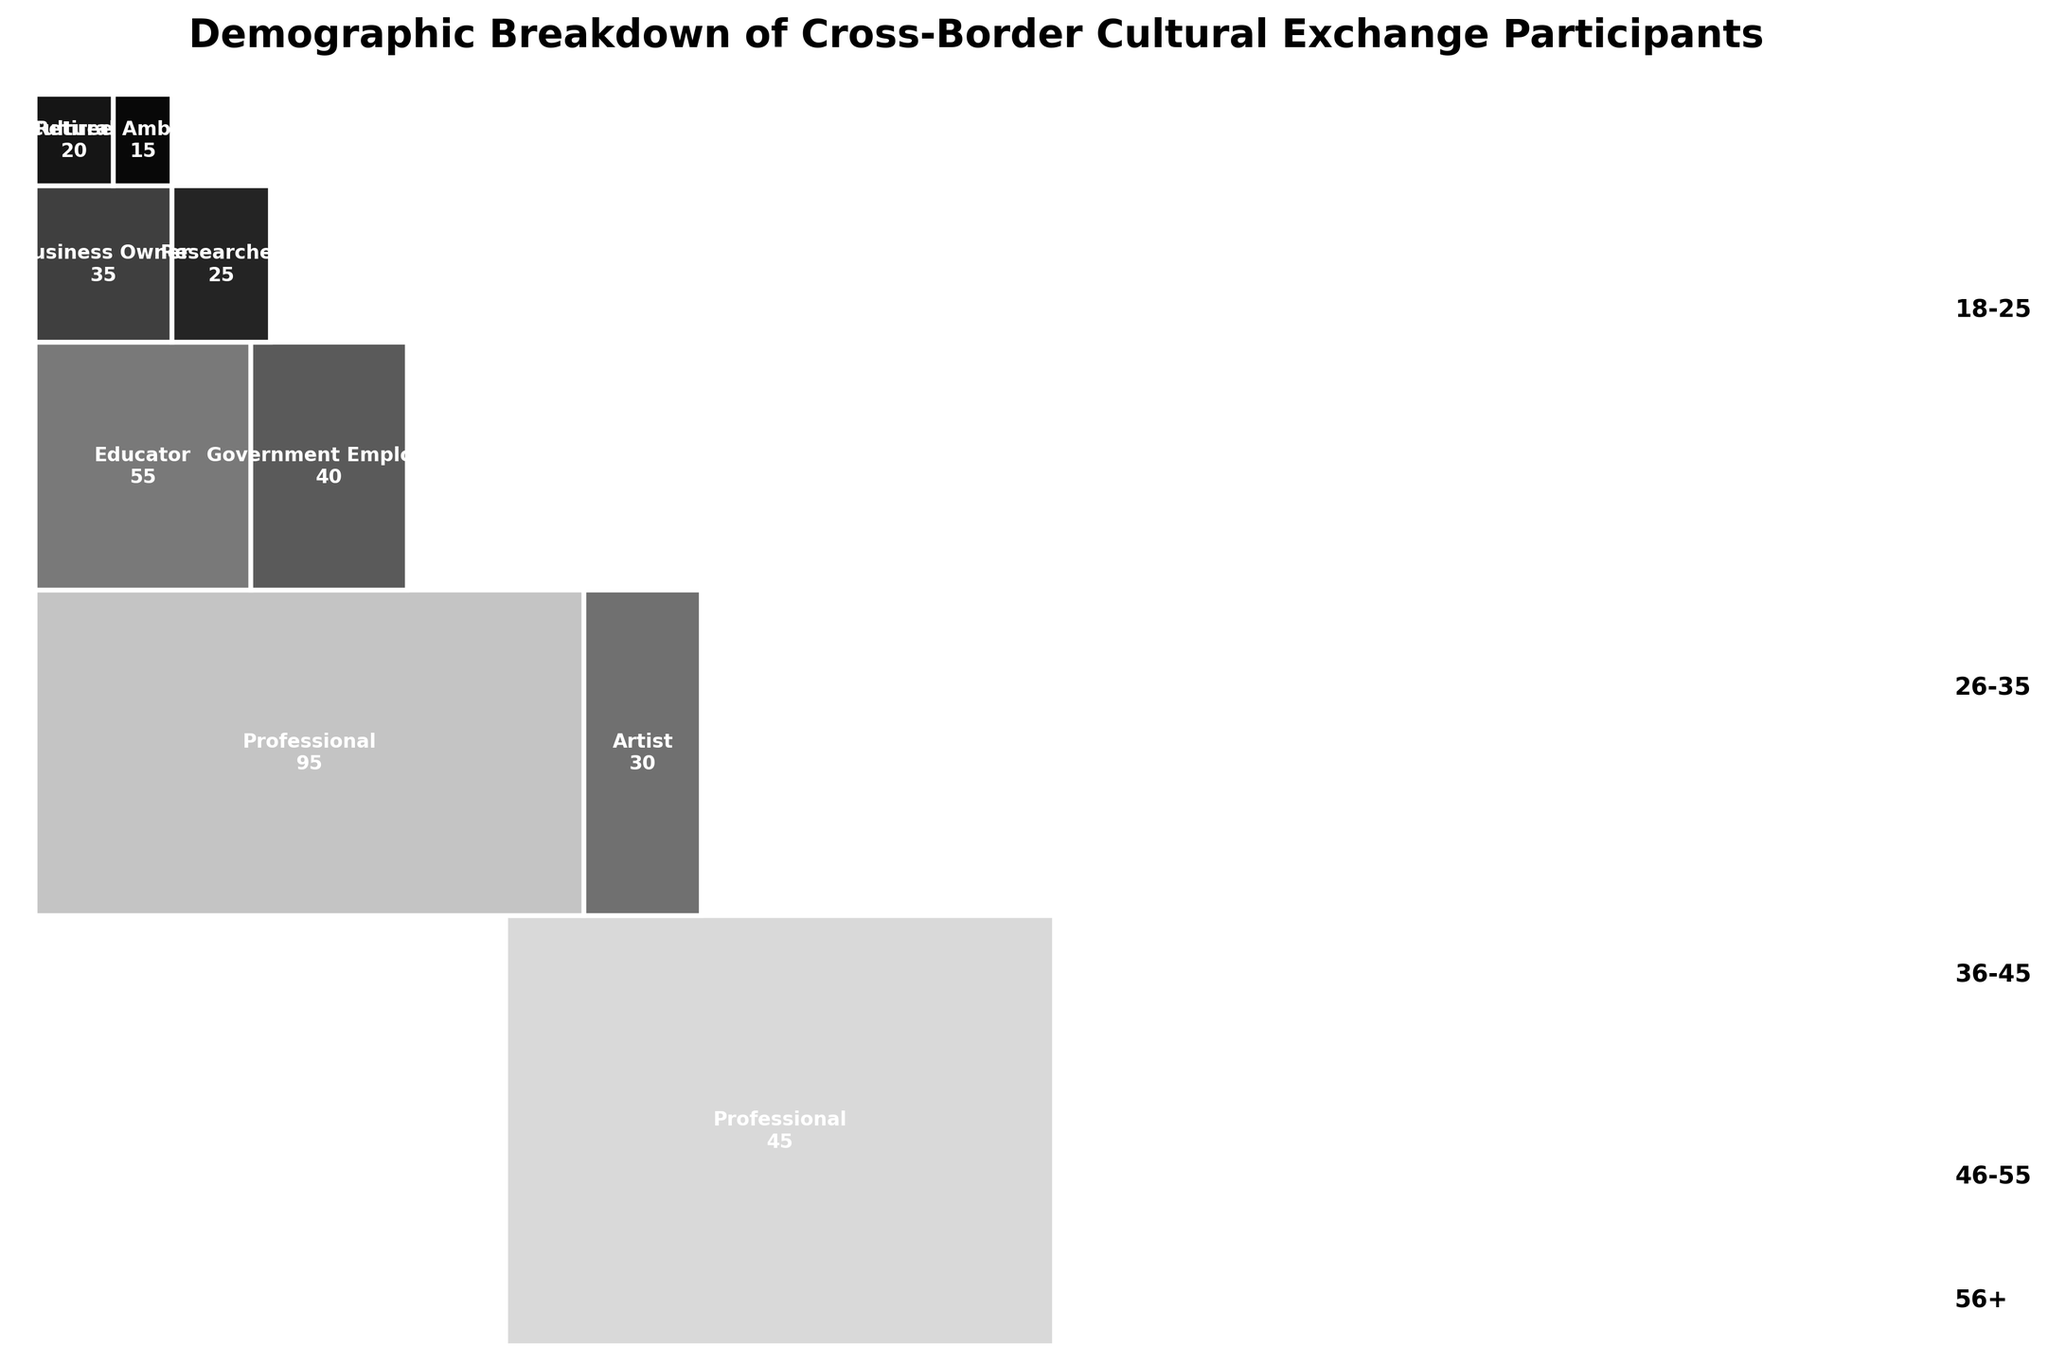What is the title of the plot? The title of the plot is typically displayed at the top of the figure. In this case, it reads "Demographic Breakdown of Cross-Border Cultural Exchange Participants."
Answer: Demographic Breakdown of Cross-Border Cultural Exchange Participants Which age group has the highest number of participants? To determine the age group with the highest number of participants, look for the largest area in the mosaic plot since the area represents the proportion of participants.
Answer: 18-25 How many professional participants are there in the 26-35 age group? Identify the section in the mosaic plot labelled for the 26-35 age group and then find the part within that age group labelled "Professional." The number printed inside this section will provide the answer.
Answer: 95 What is the total number of participants in the 36-45 age group? Sum the numbers for each occupation within the 36-45 age group from the plot. Here, the occupations are Educator (55) and Government Employee (40), so the total is 55 + 40.
Answer: 95 Compare the number of participants in the 18-25 age group who are professionals to those in the 46-55 age group who are business owners. Which group has more participants? Find the sections for "Professional" in the 18-25 age group (45 participants) and "Business Owner" in the 46-55 age group (35 participants).
Answer: 18-25 Professionals Which occupation has the least number of participants in the 56+ age group? In the mosaic plot, locate the sections for the 56+ age group and compare the participant numbers of the labeled occupations, which are Retiree (20) and Cultural Ambassador (15).
Answer: Cultural Ambassador Is the proportion of students in the 18-25 age group higher than the proportion of educators in the 36-45 age group? Compare the area sizes for "Student" in the 18-25 age group and "Educator" in the 36-45 age group in the mosaic plot. The larger area corresponds to a higher proportion.
Answer: Yes What's the proportion of participants who are government employees in the 36-45 age group compared to the total participants? Look at the section for "Government Employee" in the 36-45 age group. There are 40 government employees. The total number of participants is 480. The proportion is 40/480.
Answer: 0.083 (8.3%) Which age group contributes the second-highest number of participants overall? Assess the contribution of each age group by considering the area they cover and checking the printed numbers, then identify the second largest.
Answer: 26-35 How does the participation of retirees compare to business owners? Find and compare the sections labeled "Retiree" and "Business Owner” in the respective age groups; Retirees (20) and Business Owners (35).
Answer: Business Owners > Retirees 